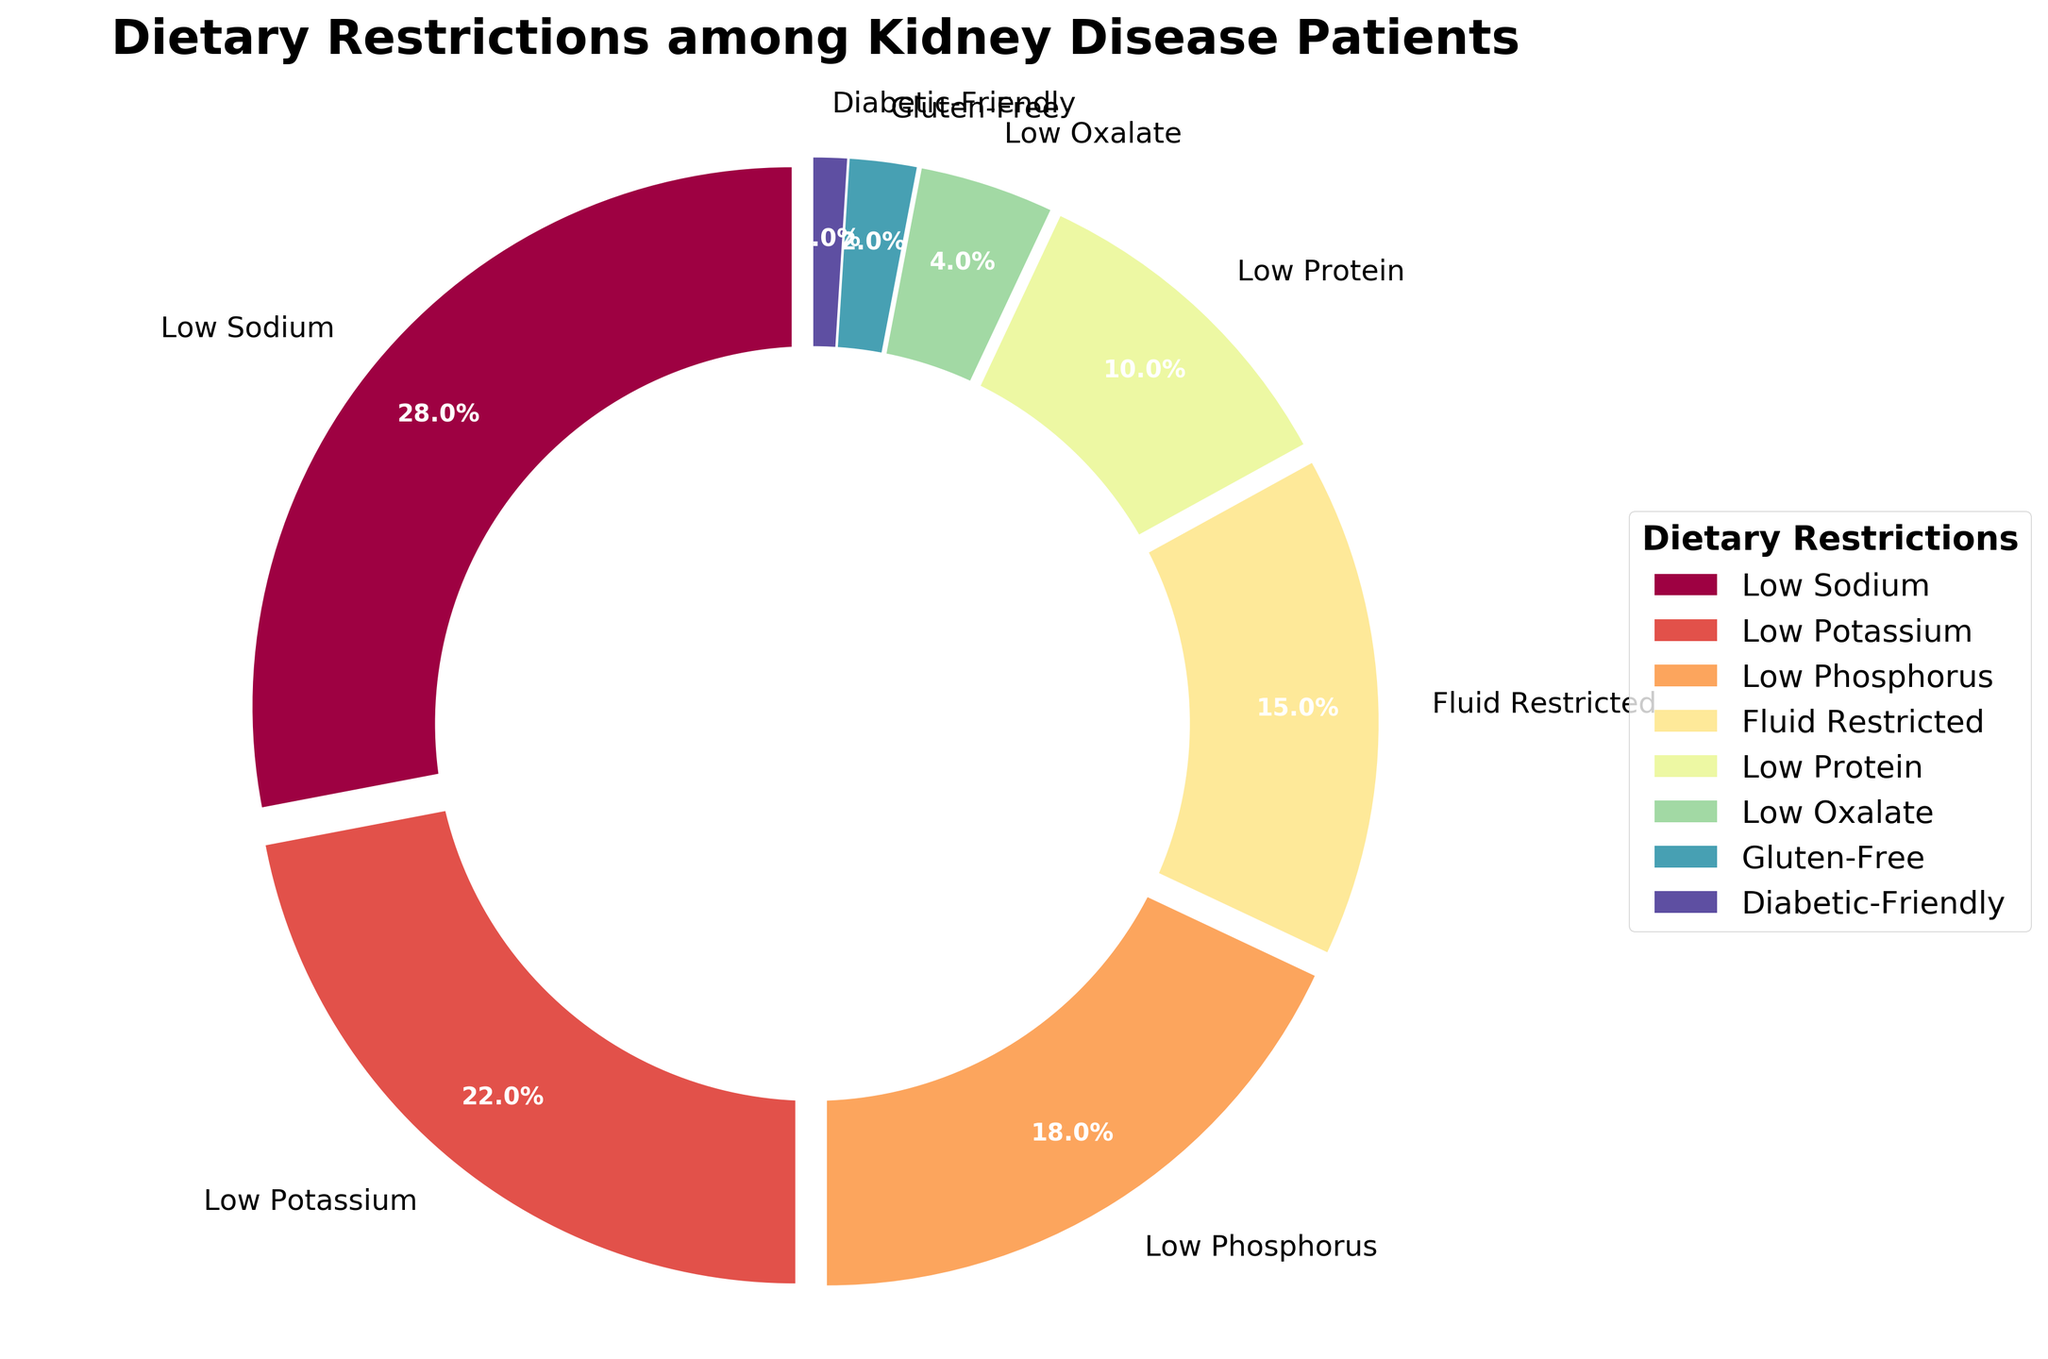Which dietary restriction has the highest percentage? Look at the largest segment of the pie chart. The segment with "Low Sodium" has the highest percentage value of 28%.
Answer: Low Sodium Which dietary restriction is most common after Low Sodium? Check the next largest segment after "Low Sodium". The "Low Potassium" segment is the second-largest with a percentage value of 22%.
Answer: Low Potassium How much larger is the percentage of Low Sodium compared to Low Phosphorus? Subtract the percentage of "Low Phosphorus" from the percentage of "Low Sodium". It's 28% - 18% = 10%.
Answer: 10% Which two dietary restrictions combined make up exactly 50%? Add percentages of different combinations to find the sum. The combination of "Low Sodium" (28%) and "Low Potassium" (22%) meets the criteria: 28% + 22% = 50%.
Answer: Low Sodium and Low Potassium What is the visual attribute of the smallest segment in the pie chart? (e.g., color, size) Identify the smallest segment by looking for "Diabetic-Friendly" with 1%. Its color is the smallest and likely less vibrant compared to larger segments.
Answer: Small segment, likely least vibrant color Compare the percentages of Fluid Restricted and Low Protein. Which is greater? Look at both segments, "Fluid Restricted" has 15%, and "Low Protein" has 10%. Therefore, Fluid Restricted (15%) is greater than Low Protein (10%).
Answer: Fluid Restricted is greater What is the combined percentage of Low Oxalate, Gluten-Free, and Diabetic-Friendly dietary restrictions? Sum the percentages of "Low Oxalate" (4%), "Gluten-Free" (2%), and "Diabetic-Friendly" (1%): 4% + 2% + 1% = 7%.
Answer: 7% Is the percentage of Low Potassium dietary restriction more than double that of Low Oxalate? Compare twice the percentage of Low Oxalate (2 * 4% = 8%) with "Low Potassium" (22%). Since 22% > 8%, the statement is true.
Answer: Yes How do the visual attributes and legend aid in understanding the chart's information? The different colors in the segments and the exploded view help distinguish each dietary restriction. The legend aligns each color with its restriction type for easy identification.
Answer: Colors and legend help distinguish and identify Which dietary restrictions have percentages less than 5%? Identify segments with values below 5%. These are "Low Oxalate" (4%), "Gluten-Free" (2%), and "Diabetic-Friendly" (1%).
Answer: Low Oxalate, Gluten-Free, and Diabetic-Friendly 